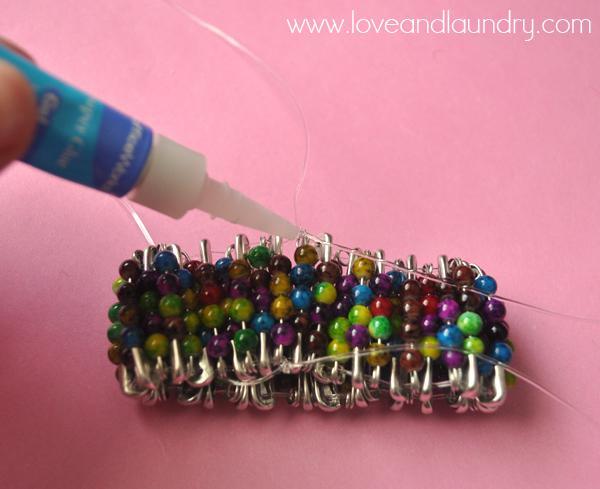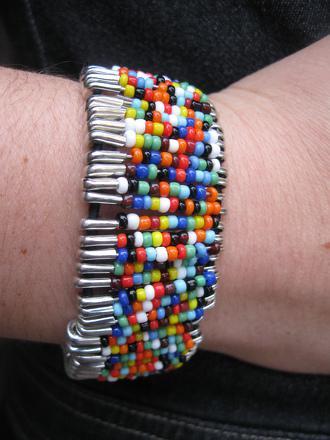The first image is the image on the left, the second image is the image on the right. For the images displayed, is the sentence "An image shows an unworn bracelet made of silver safety pins strung with different bead colors." factually correct? Answer yes or no. Yes. The first image is the image on the left, the second image is the image on the right. Analyze the images presented: Is the assertion "there is a human wearing a bracelet in each image." valid? Answer yes or no. No. 